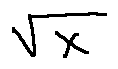<formula> <loc_0><loc_0><loc_500><loc_500>\sqrt { X }</formula> 